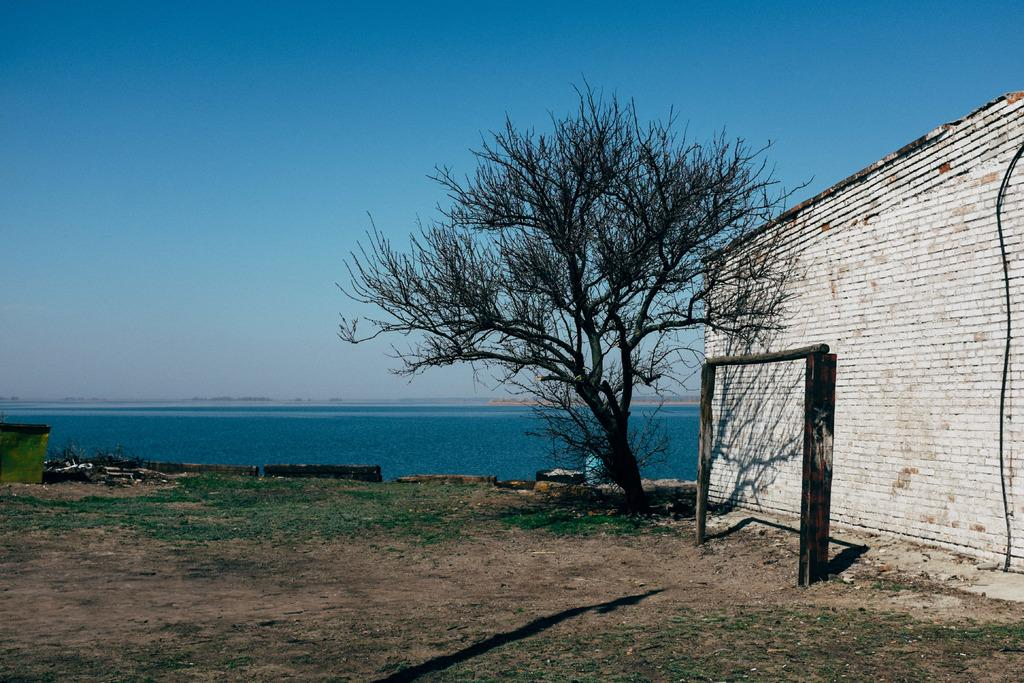What type of structure is located on the right side of the image? A: There is a brick wall on the right side of the image. What other natural element is on the right side of the image? There is a tree on the right side of the image. What can be seen in the distance in the image? There is a sea visible in the image. What is the color of the sky in the image? The sky is blue and visible at the top of the image. Can you see a crown on the tree in the image? There is no crown present on the tree in the image. What type of division is occurring in the image? There is no division or separation of elements in the image; it is a continuous scene. 